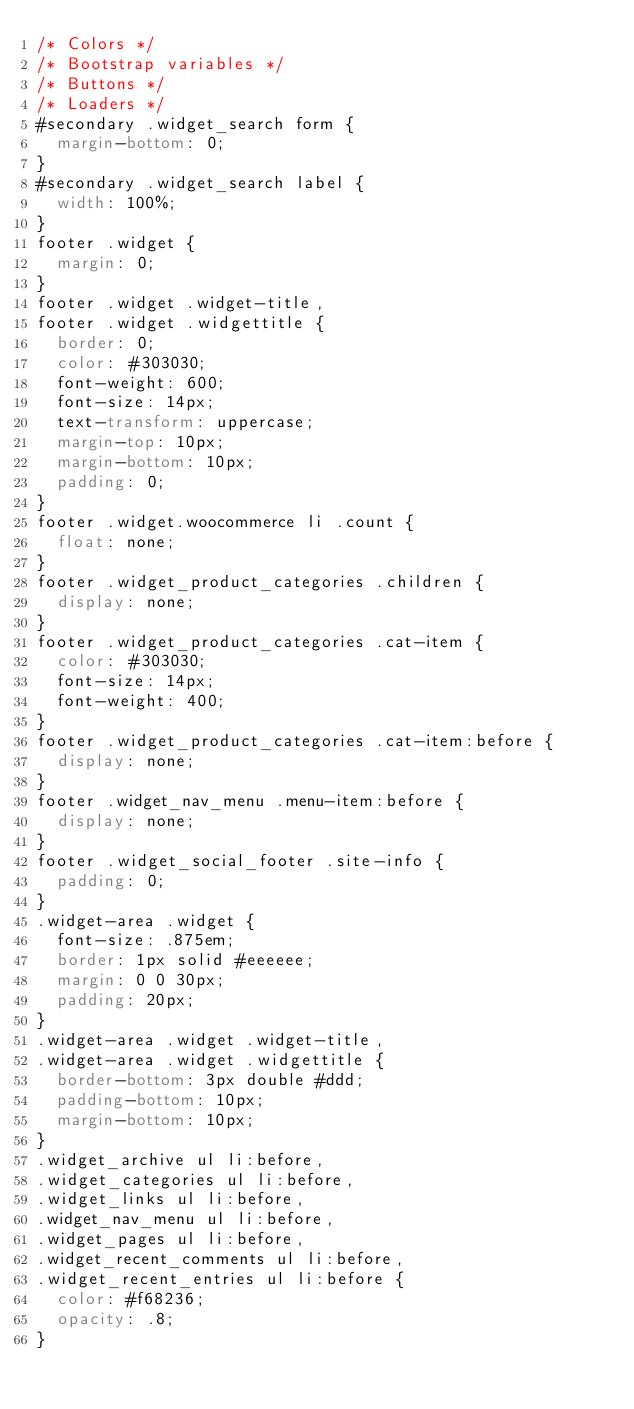<code> <loc_0><loc_0><loc_500><loc_500><_CSS_>/* Colors */
/* Bootstrap variables */
/* Buttons */
/* Loaders */
#secondary .widget_search form {
  margin-bottom: 0;
}
#secondary .widget_search label {
  width: 100%;
}
footer .widget {
  margin: 0;
}
footer .widget .widget-title,
footer .widget .widgettitle {
  border: 0;
  color: #303030;
  font-weight: 600;
  font-size: 14px;
  text-transform: uppercase;
  margin-top: 10px;
  margin-bottom: 10px;
  padding: 0;
}
footer .widget.woocommerce li .count {
  float: none;
}
footer .widget_product_categories .children {
  display: none;
}
footer .widget_product_categories .cat-item {
  color: #303030;
  font-size: 14px;
  font-weight: 400;
}
footer .widget_product_categories .cat-item:before {
  display: none;
}
footer .widget_nav_menu .menu-item:before {
  display: none;
}
footer .widget_social_footer .site-info {
  padding: 0;
}
.widget-area .widget {
  font-size: .875em;
  border: 1px solid #eeeeee;
  margin: 0 0 30px;
  padding: 20px;
}
.widget-area .widget .widget-title,
.widget-area .widget .widgettitle {
  border-bottom: 3px double #ddd;
  padding-bottom: 10px;
  margin-bottom: 10px;
}
.widget_archive ul li:before,
.widget_categories ul li:before,
.widget_links ul li:before,
.widget_nav_menu ul li:before,
.widget_pages ul li:before,
.widget_recent_comments ul li:before,
.widget_recent_entries ul li:before {
  color: #f68236;
  opacity: .8;
}</code> 